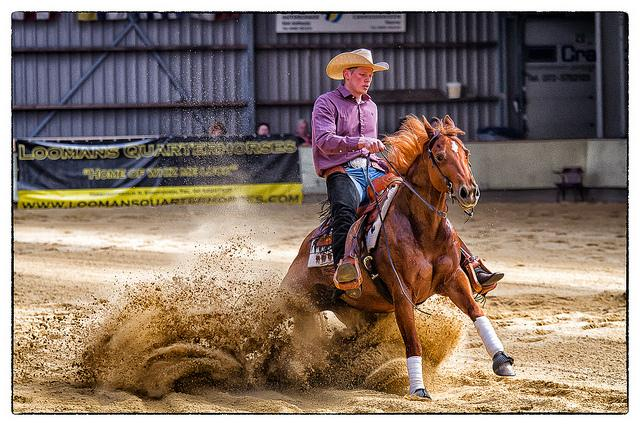What mythological creature is most similar to the one the man is riding on? Please explain your reasoning. phlegon. Phlegon is similar to the horse. 